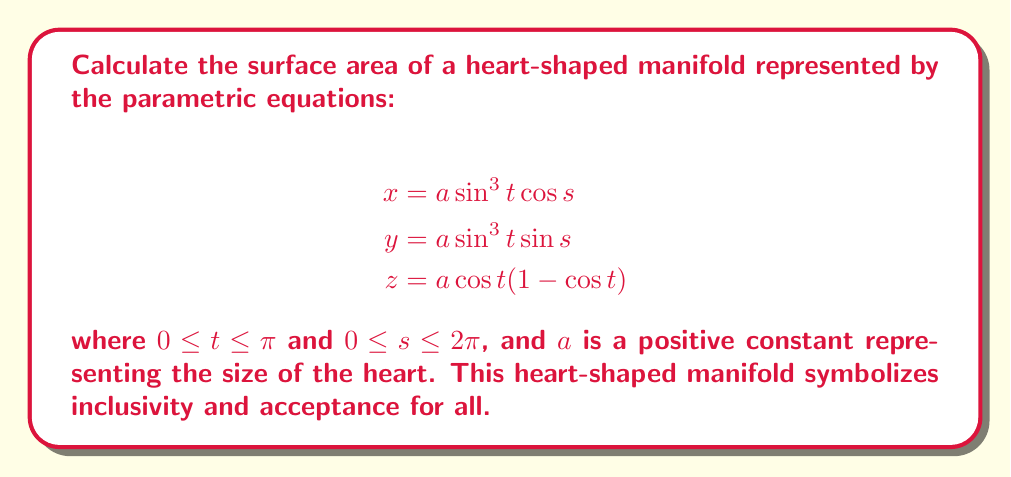Can you answer this question? To find the surface area of this heart-shaped manifold, we'll use the surface integral formula:

$$A = \int\int_S \sqrt{EG - F^2} \, ds \, dt$$

where $E$, $F$, and $G$ are the coefficients of the first fundamental form.

Step 1: Calculate partial derivatives
$$\frac{\partial x}{\partial s} = -a \sin^3 t \sin s$$
$$\frac{\partial x}{\partial t} = 3a \sin^2 t \cos t \cos s$$
$$\frac{\partial y}{\partial s} = a \sin^3 t \cos s$$
$$\frac{\partial y}{\partial t} = 3a \sin^2 t \cos t \sin s$$
$$\frac{\partial z}{\partial s} = 0$$
$$\frac{\partial z}{\partial t} = a (-\sin t + \sin t \cos t)$$

Step 2: Calculate $E$, $F$, and $G$
$$E = (\frac{\partial x}{\partial s})^2 + (\frac{\partial y}{\partial s})^2 + (\frac{\partial z}{\partial s})^2 = a^2 \sin^6 t$$
$$F = \frac{\partial x}{\partial s}\frac{\partial x}{\partial t} + \frac{\partial y}{\partial s}\frac{\partial y}{\partial t} + \frac{\partial z}{\partial s}\frac{\partial z}{\partial t} = 0$$
$$G = (\frac{\partial x}{\partial t})^2 + (\frac{\partial y}{\partial t})^2 + (\frac{\partial z}{\partial t})^2 = a^2 (9 \sin^4 t \cos^2 t + \sin^2 t - 2 \sin^2 t \cos t + \sin^2 t \cos^2 t)$$

Step 3: Simplify $EG - F^2$
$$EG - F^2 = a^4 \sin^6 t (9 \sin^4 t \cos^2 t + \sin^2 t - 2 \sin^2 t \cos t + \sin^2 t \cos^2 t)$$

Step 4: Set up the surface integral
$$A = \int_0^{2\pi} \int_0^{\pi} a^2 \sin^3 t \sqrt{9 \sin^4 t \cos^2 t + \sin^2 t - 2 \sin^2 t \cos t + \sin^2 t \cos^2 t} \, dt \, ds$$

Step 5: Integrate with respect to $s$
$$A = 2\pi a^2 \int_0^{\pi} \sin^3 t \sqrt{9 \sin^4 t \cos^2 t + \sin^2 t - 2 \sin^2 t \cos t + \sin^2 t \cos^2 t} \, dt$$

Step 6: The remaining integral doesn't have a closed-form solution, so we express the final answer in terms of this definite integral.
Answer: $A = 2\pi a^2 \int_0^{\pi} \sin^3 t \sqrt{9 \sin^4 t \cos^2 t + \sin^2 t - 2 \sin^2 t \cos t + \sin^2 t \cos^2 t} \, dt$ 